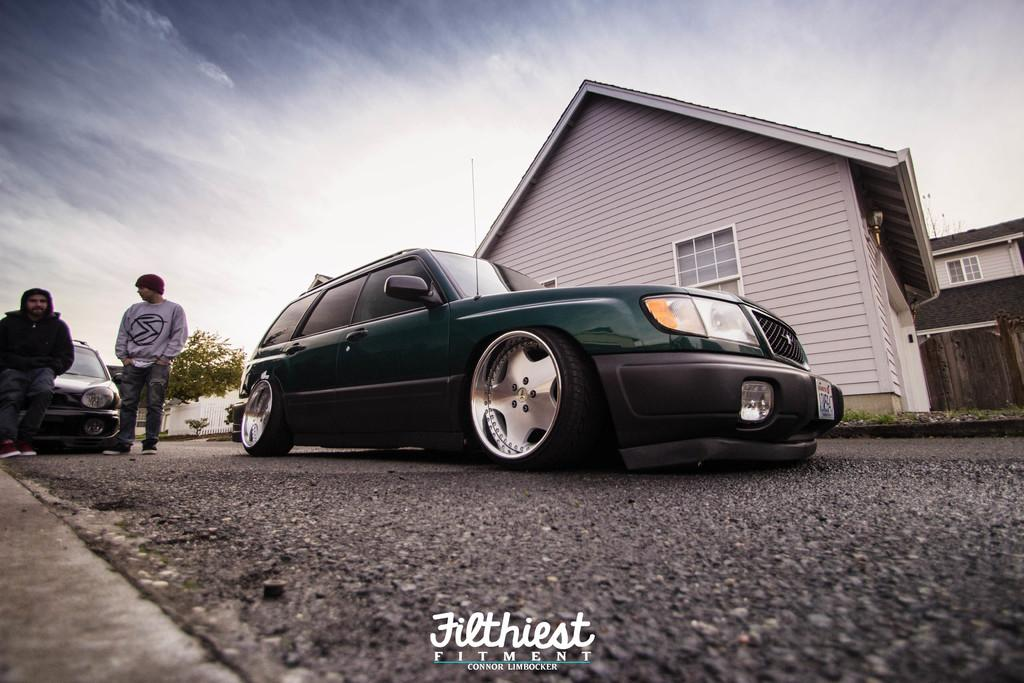What type of structure is visible in the image? There is a house in the image. What is surrounding the house? There is fencing in the image. What type of vehicles can be seen in the image? There are cars in the image. Are there any living beings present in the image? Yes, there are people in the image. What type of natural elements are present in the image? There are trees and plants in the image. What type of leather is being used by the carpenter in the image? There is no carpenter or leather present in the image. What class of people are depicted in the image? The image does not depict any specific class of people; it simply shows people in general. 